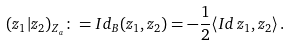Convert formula to latex. <formula><loc_0><loc_0><loc_500><loc_500>( z _ { 1 } | z _ { 2 } ) _ { Z _ { a } } \colon = I d _ { B } ( z _ { 1 } , z _ { 2 } ) = - \frac { 1 } { 2 } \langle I d \, z _ { 1 } , z _ { 2 } \rangle \, .</formula> 